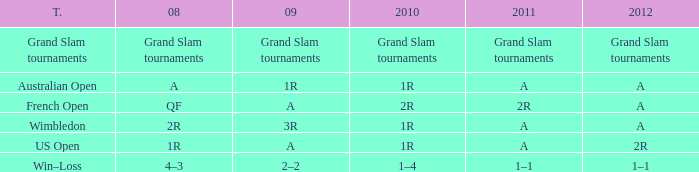Name the 2010 for tournament of us open 1R. 